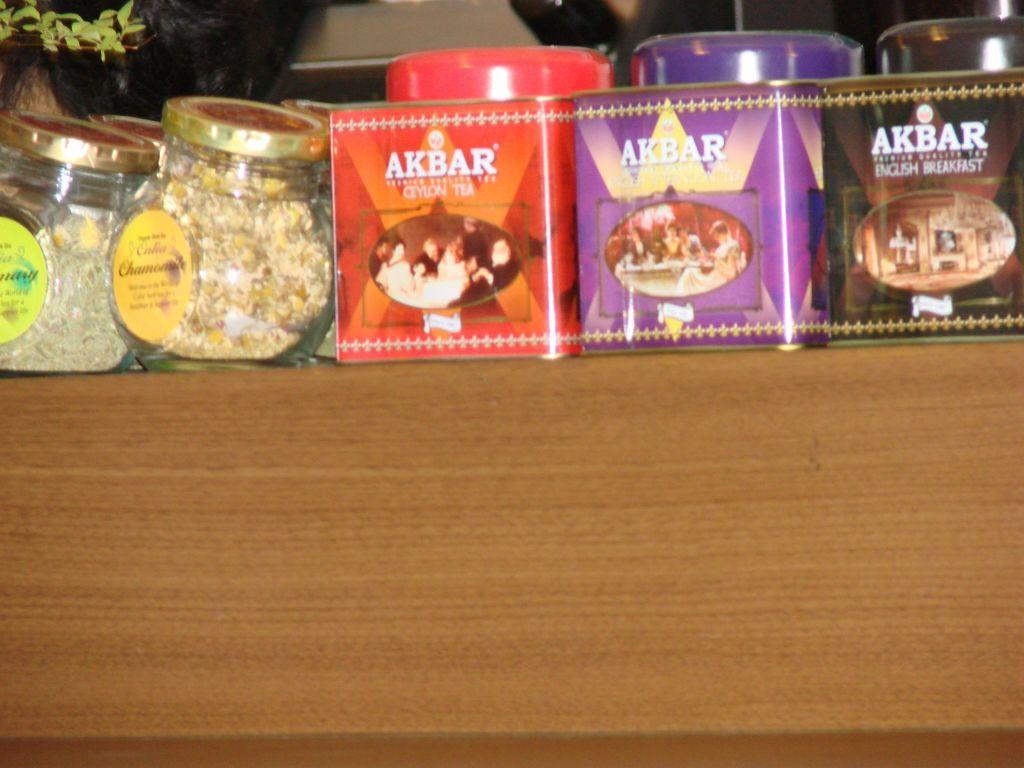What type of objects can be seen in the image? There are containers and many boxes in the image. What is the color of the surface in the image? The surface in the image is brown. Is there any vegetation visible in the image? Yes, there is a plant to the left in the image. Can you see any visible veins on the plant in the image? There is no information about the visibility of veins on the plant in the image. Are there any giants interacting with the containers in the image? There is no mention of giants or any other beings interacting with the containers in the image. 